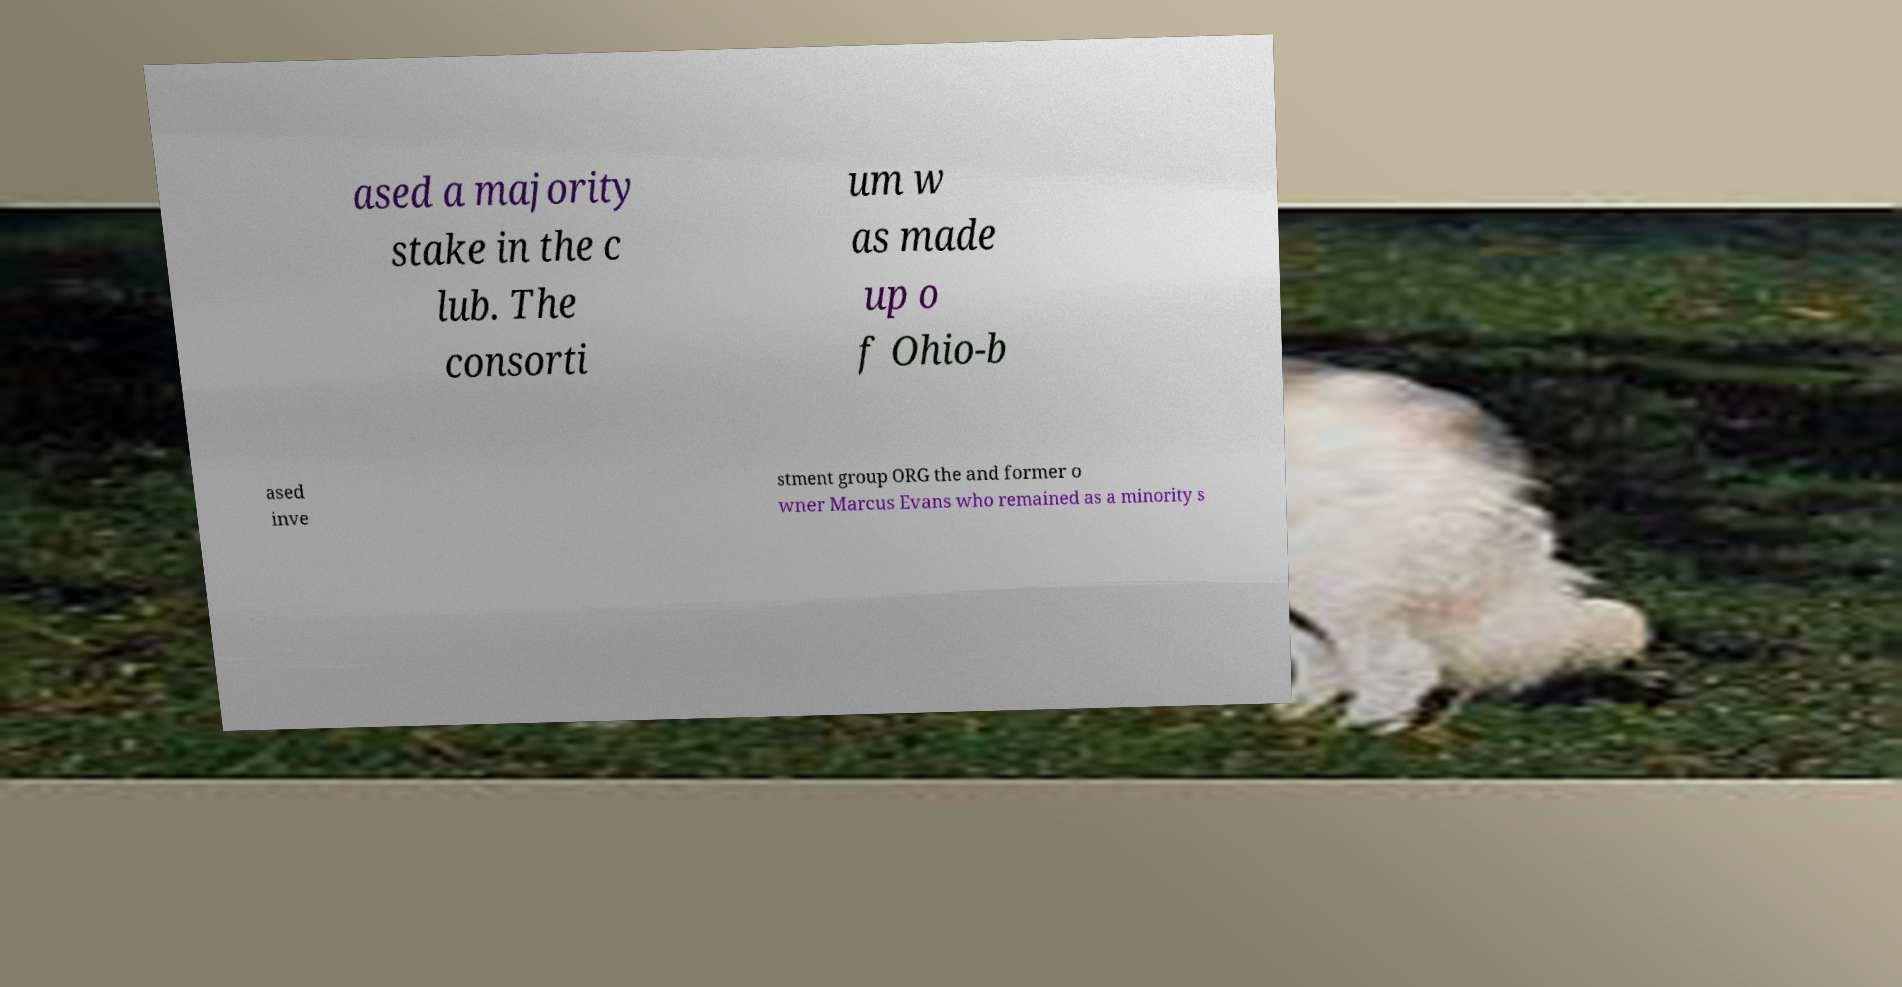Can you accurately transcribe the text from the provided image for me? ased a majority stake in the c lub. The consorti um w as made up o f Ohio-b ased inve stment group ORG the and former o wner Marcus Evans who remained as a minority s 